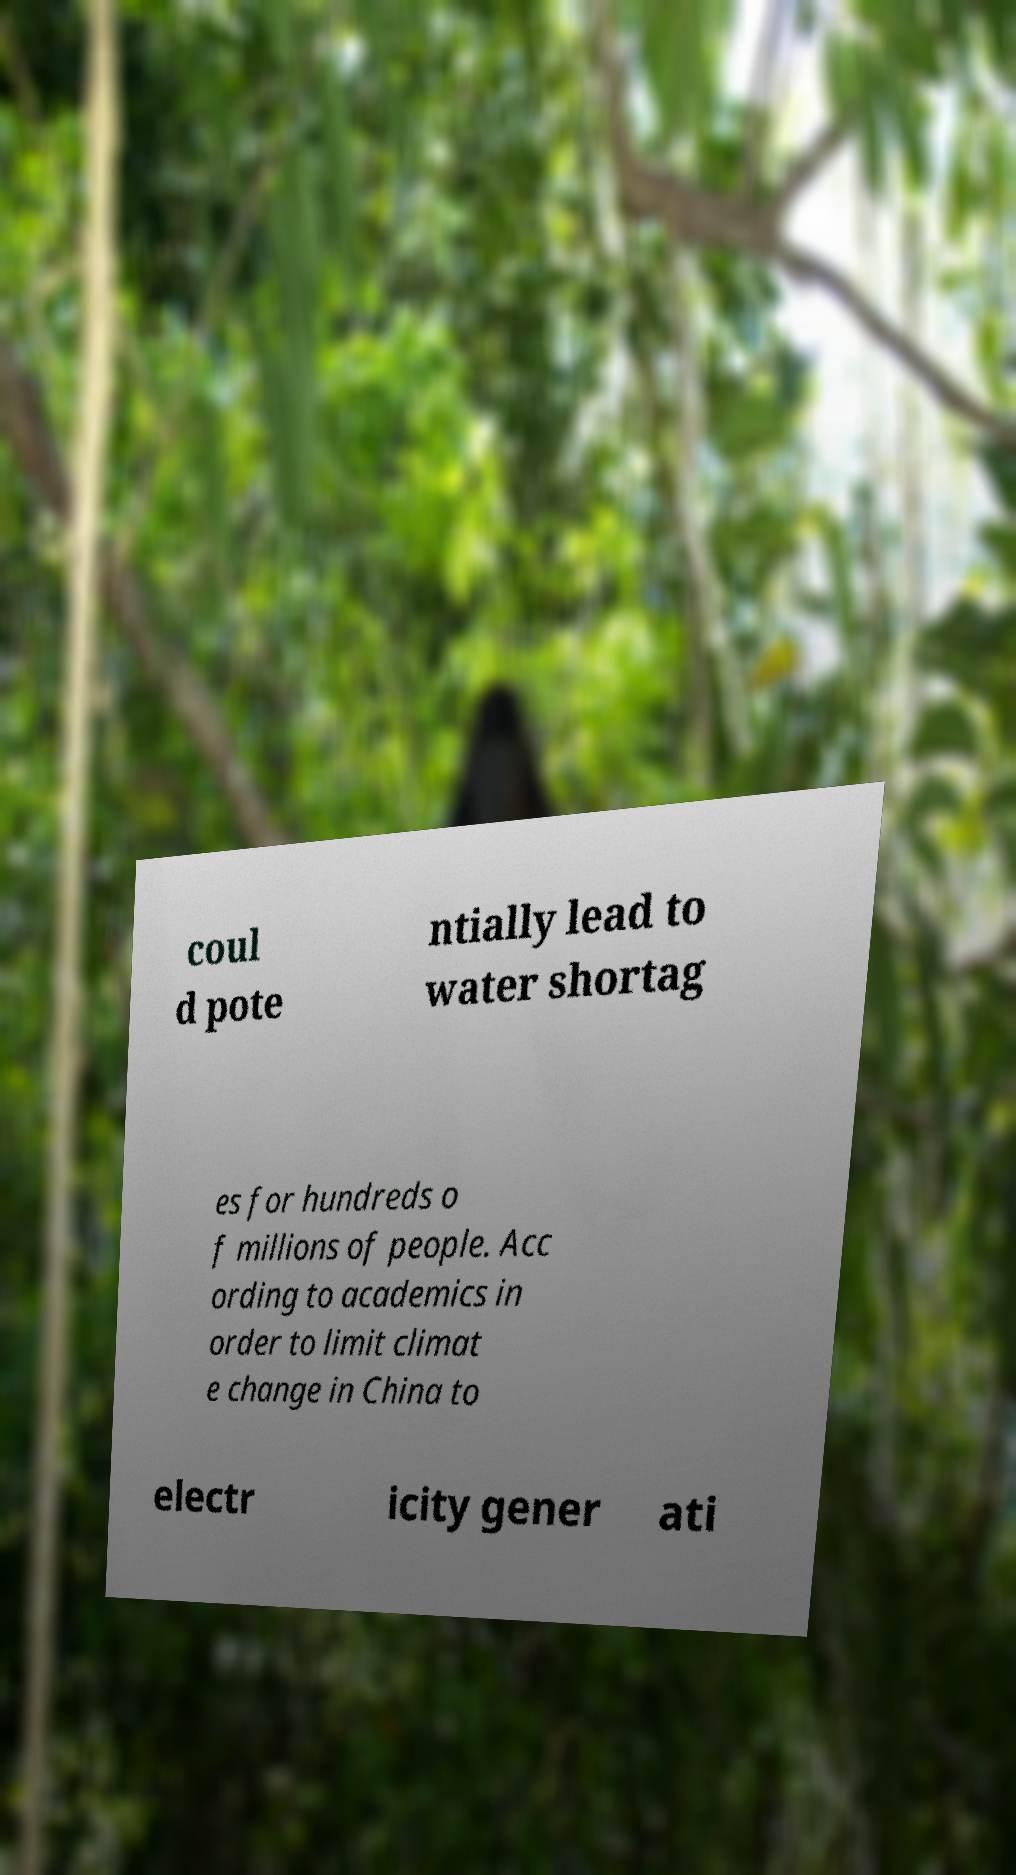Could you extract and type out the text from this image? coul d pote ntially lead to water shortag es for hundreds o f millions of people. Acc ording to academics in order to limit climat e change in China to electr icity gener ati 